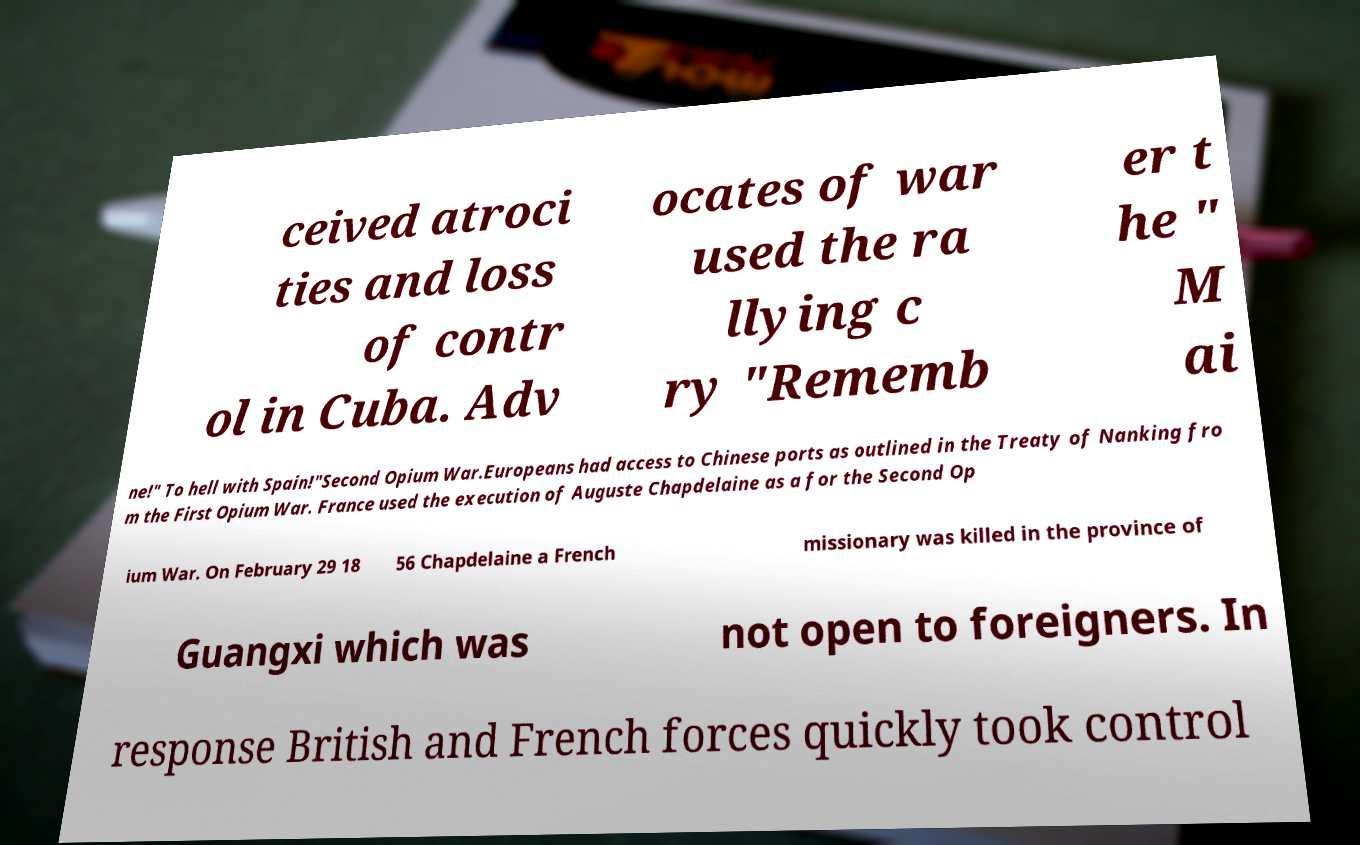Please identify and transcribe the text found in this image. ceived atroci ties and loss of contr ol in Cuba. Adv ocates of war used the ra llying c ry "Rememb er t he " M ai ne!" To hell with Spain!"Second Opium War.Europeans had access to Chinese ports as outlined in the Treaty of Nanking fro m the First Opium War. France used the execution of Auguste Chapdelaine as a for the Second Op ium War. On February 29 18 56 Chapdelaine a French missionary was killed in the province of Guangxi which was not open to foreigners. In response British and French forces quickly took control 